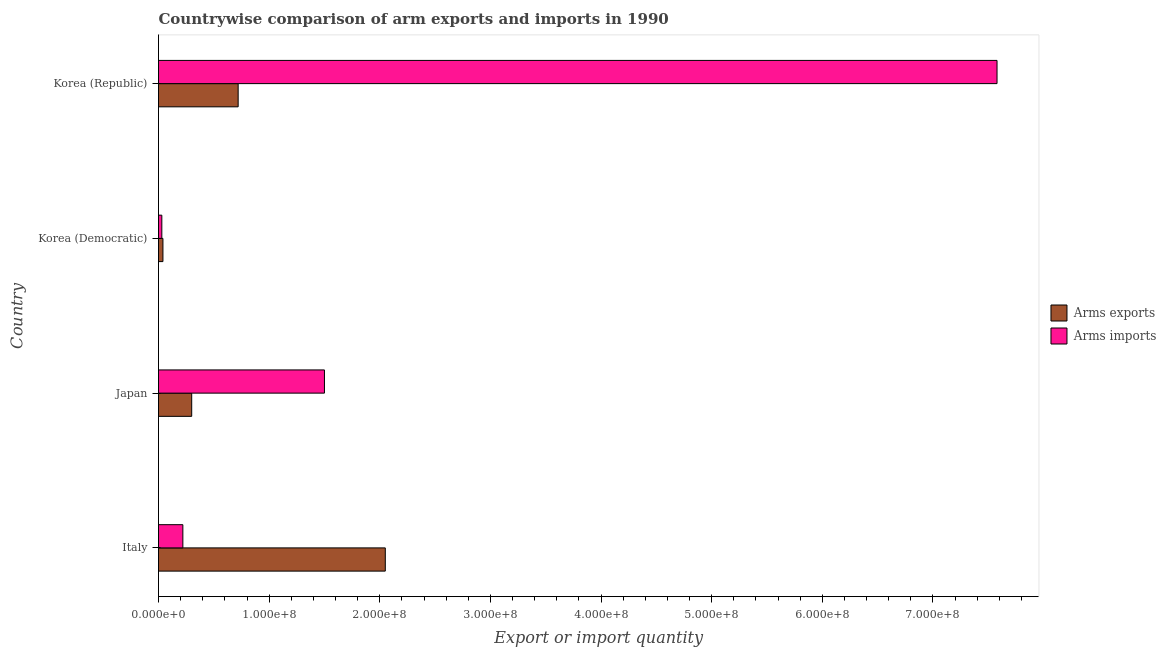How many different coloured bars are there?
Keep it short and to the point. 2. How many bars are there on the 1st tick from the top?
Offer a terse response. 2. In how many cases, is the number of bars for a given country not equal to the number of legend labels?
Give a very brief answer. 0. What is the arms imports in Japan?
Your response must be concise. 1.50e+08. Across all countries, what is the maximum arms exports?
Your response must be concise. 2.05e+08. Across all countries, what is the minimum arms imports?
Keep it short and to the point. 3.00e+06. In which country was the arms imports minimum?
Provide a succinct answer. Korea (Democratic). What is the total arms exports in the graph?
Give a very brief answer. 3.11e+08. What is the difference between the arms imports in Italy and that in Korea (Republic)?
Your answer should be very brief. -7.36e+08. What is the difference between the arms imports in Japan and the arms exports in Italy?
Your response must be concise. -5.50e+07. What is the average arms imports per country?
Your answer should be compact. 2.33e+08. What is the difference between the arms exports and arms imports in Japan?
Provide a succinct answer. -1.20e+08. In how many countries, is the arms imports greater than 180000000 ?
Provide a succinct answer. 1. What is the ratio of the arms exports in Italy to that in Korea (Democratic)?
Ensure brevity in your answer.  51.25. Is the difference between the arms exports in Japan and Korea (Democratic) greater than the difference between the arms imports in Japan and Korea (Democratic)?
Offer a terse response. No. What is the difference between the highest and the second highest arms exports?
Offer a very short reply. 1.33e+08. What is the difference between the highest and the lowest arms exports?
Ensure brevity in your answer.  2.01e+08. What does the 2nd bar from the top in Korea (Democratic) represents?
Your answer should be compact. Arms exports. What does the 2nd bar from the bottom in Korea (Democratic) represents?
Your answer should be very brief. Arms imports. How many bars are there?
Provide a short and direct response. 8. How many countries are there in the graph?
Offer a very short reply. 4. Does the graph contain any zero values?
Ensure brevity in your answer.  No. What is the title of the graph?
Keep it short and to the point. Countrywise comparison of arm exports and imports in 1990. What is the label or title of the X-axis?
Offer a very short reply. Export or import quantity. What is the label or title of the Y-axis?
Your answer should be very brief. Country. What is the Export or import quantity of Arms exports in Italy?
Offer a very short reply. 2.05e+08. What is the Export or import quantity of Arms imports in Italy?
Offer a terse response. 2.20e+07. What is the Export or import quantity of Arms exports in Japan?
Make the answer very short. 3.00e+07. What is the Export or import quantity in Arms imports in Japan?
Provide a succinct answer. 1.50e+08. What is the Export or import quantity of Arms exports in Korea (Democratic)?
Your response must be concise. 4.00e+06. What is the Export or import quantity in Arms exports in Korea (Republic)?
Your response must be concise. 7.20e+07. What is the Export or import quantity in Arms imports in Korea (Republic)?
Give a very brief answer. 7.58e+08. Across all countries, what is the maximum Export or import quantity in Arms exports?
Give a very brief answer. 2.05e+08. Across all countries, what is the maximum Export or import quantity in Arms imports?
Your response must be concise. 7.58e+08. What is the total Export or import quantity of Arms exports in the graph?
Offer a terse response. 3.11e+08. What is the total Export or import quantity of Arms imports in the graph?
Offer a terse response. 9.33e+08. What is the difference between the Export or import quantity of Arms exports in Italy and that in Japan?
Offer a terse response. 1.75e+08. What is the difference between the Export or import quantity in Arms imports in Italy and that in Japan?
Offer a very short reply. -1.28e+08. What is the difference between the Export or import quantity of Arms exports in Italy and that in Korea (Democratic)?
Keep it short and to the point. 2.01e+08. What is the difference between the Export or import quantity of Arms imports in Italy and that in Korea (Democratic)?
Make the answer very short. 1.90e+07. What is the difference between the Export or import quantity in Arms exports in Italy and that in Korea (Republic)?
Your response must be concise. 1.33e+08. What is the difference between the Export or import quantity of Arms imports in Italy and that in Korea (Republic)?
Give a very brief answer. -7.36e+08. What is the difference between the Export or import quantity of Arms exports in Japan and that in Korea (Democratic)?
Offer a very short reply. 2.60e+07. What is the difference between the Export or import quantity of Arms imports in Japan and that in Korea (Democratic)?
Keep it short and to the point. 1.47e+08. What is the difference between the Export or import quantity in Arms exports in Japan and that in Korea (Republic)?
Offer a very short reply. -4.20e+07. What is the difference between the Export or import quantity of Arms imports in Japan and that in Korea (Republic)?
Offer a terse response. -6.08e+08. What is the difference between the Export or import quantity in Arms exports in Korea (Democratic) and that in Korea (Republic)?
Offer a very short reply. -6.80e+07. What is the difference between the Export or import quantity in Arms imports in Korea (Democratic) and that in Korea (Republic)?
Your response must be concise. -7.55e+08. What is the difference between the Export or import quantity of Arms exports in Italy and the Export or import quantity of Arms imports in Japan?
Your answer should be compact. 5.50e+07. What is the difference between the Export or import quantity in Arms exports in Italy and the Export or import quantity in Arms imports in Korea (Democratic)?
Your answer should be very brief. 2.02e+08. What is the difference between the Export or import quantity of Arms exports in Italy and the Export or import quantity of Arms imports in Korea (Republic)?
Provide a short and direct response. -5.53e+08. What is the difference between the Export or import quantity of Arms exports in Japan and the Export or import quantity of Arms imports in Korea (Democratic)?
Ensure brevity in your answer.  2.70e+07. What is the difference between the Export or import quantity of Arms exports in Japan and the Export or import quantity of Arms imports in Korea (Republic)?
Your answer should be very brief. -7.28e+08. What is the difference between the Export or import quantity in Arms exports in Korea (Democratic) and the Export or import quantity in Arms imports in Korea (Republic)?
Give a very brief answer. -7.54e+08. What is the average Export or import quantity in Arms exports per country?
Your answer should be very brief. 7.78e+07. What is the average Export or import quantity in Arms imports per country?
Your response must be concise. 2.33e+08. What is the difference between the Export or import quantity in Arms exports and Export or import quantity in Arms imports in Italy?
Offer a terse response. 1.83e+08. What is the difference between the Export or import quantity in Arms exports and Export or import quantity in Arms imports in Japan?
Ensure brevity in your answer.  -1.20e+08. What is the difference between the Export or import quantity of Arms exports and Export or import quantity of Arms imports in Korea (Democratic)?
Provide a succinct answer. 1.00e+06. What is the difference between the Export or import quantity in Arms exports and Export or import quantity in Arms imports in Korea (Republic)?
Keep it short and to the point. -6.86e+08. What is the ratio of the Export or import quantity of Arms exports in Italy to that in Japan?
Give a very brief answer. 6.83. What is the ratio of the Export or import quantity of Arms imports in Italy to that in Japan?
Give a very brief answer. 0.15. What is the ratio of the Export or import quantity in Arms exports in Italy to that in Korea (Democratic)?
Your answer should be compact. 51.25. What is the ratio of the Export or import quantity of Arms imports in Italy to that in Korea (Democratic)?
Provide a short and direct response. 7.33. What is the ratio of the Export or import quantity in Arms exports in Italy to that in Korea (Republic)?
Your response must be concise. 2.85. What is the ratio of the Export or import quantity in Arms imports in Italy to that in Korea (Republic)?
Provide a short and direct response. 0.03. What is the ratio of the Export or import quantity of Arms imports in Japan to that in Korea (Democratic)?
Your response must be concise. 50. What is the ratio of the Export or import quantity of Arms exports in Japan to that in Korea (Republic)?
Offer a terse response. 0.42. What is the ratio of the Export or import quantity of Arms imports in Japan to that in Korea (Republic)?
Make the answer very short. 0.2. What is the ratio of the Export or import quantity of Arms exports in Korea (Democratic) to that in Korea (Republic)?
Offer a terse response. 0.06. What is the ratio of the Export or import quantity of Arms imports in Korea (Democratic) to that in Korea (Republic)?
Your answer should be very brief. 0. What is the difference between the highest and the second highest Export or import quantity in Arms exports?
Provide a succinct answer. 1.33e+08. What is the difference between the highest and the second highest Export or import quantity of Arms imports?
Your response must be concise. 6.08e+08. What is the difference between the highest and the lowest Export or import quantity of Arms exports?
Make the answer very short. 2.01e+08. What is the difference between the highest and the lowest Export or import quantity in Arms imports?
Give a very brief answer. 7.55e+08. 